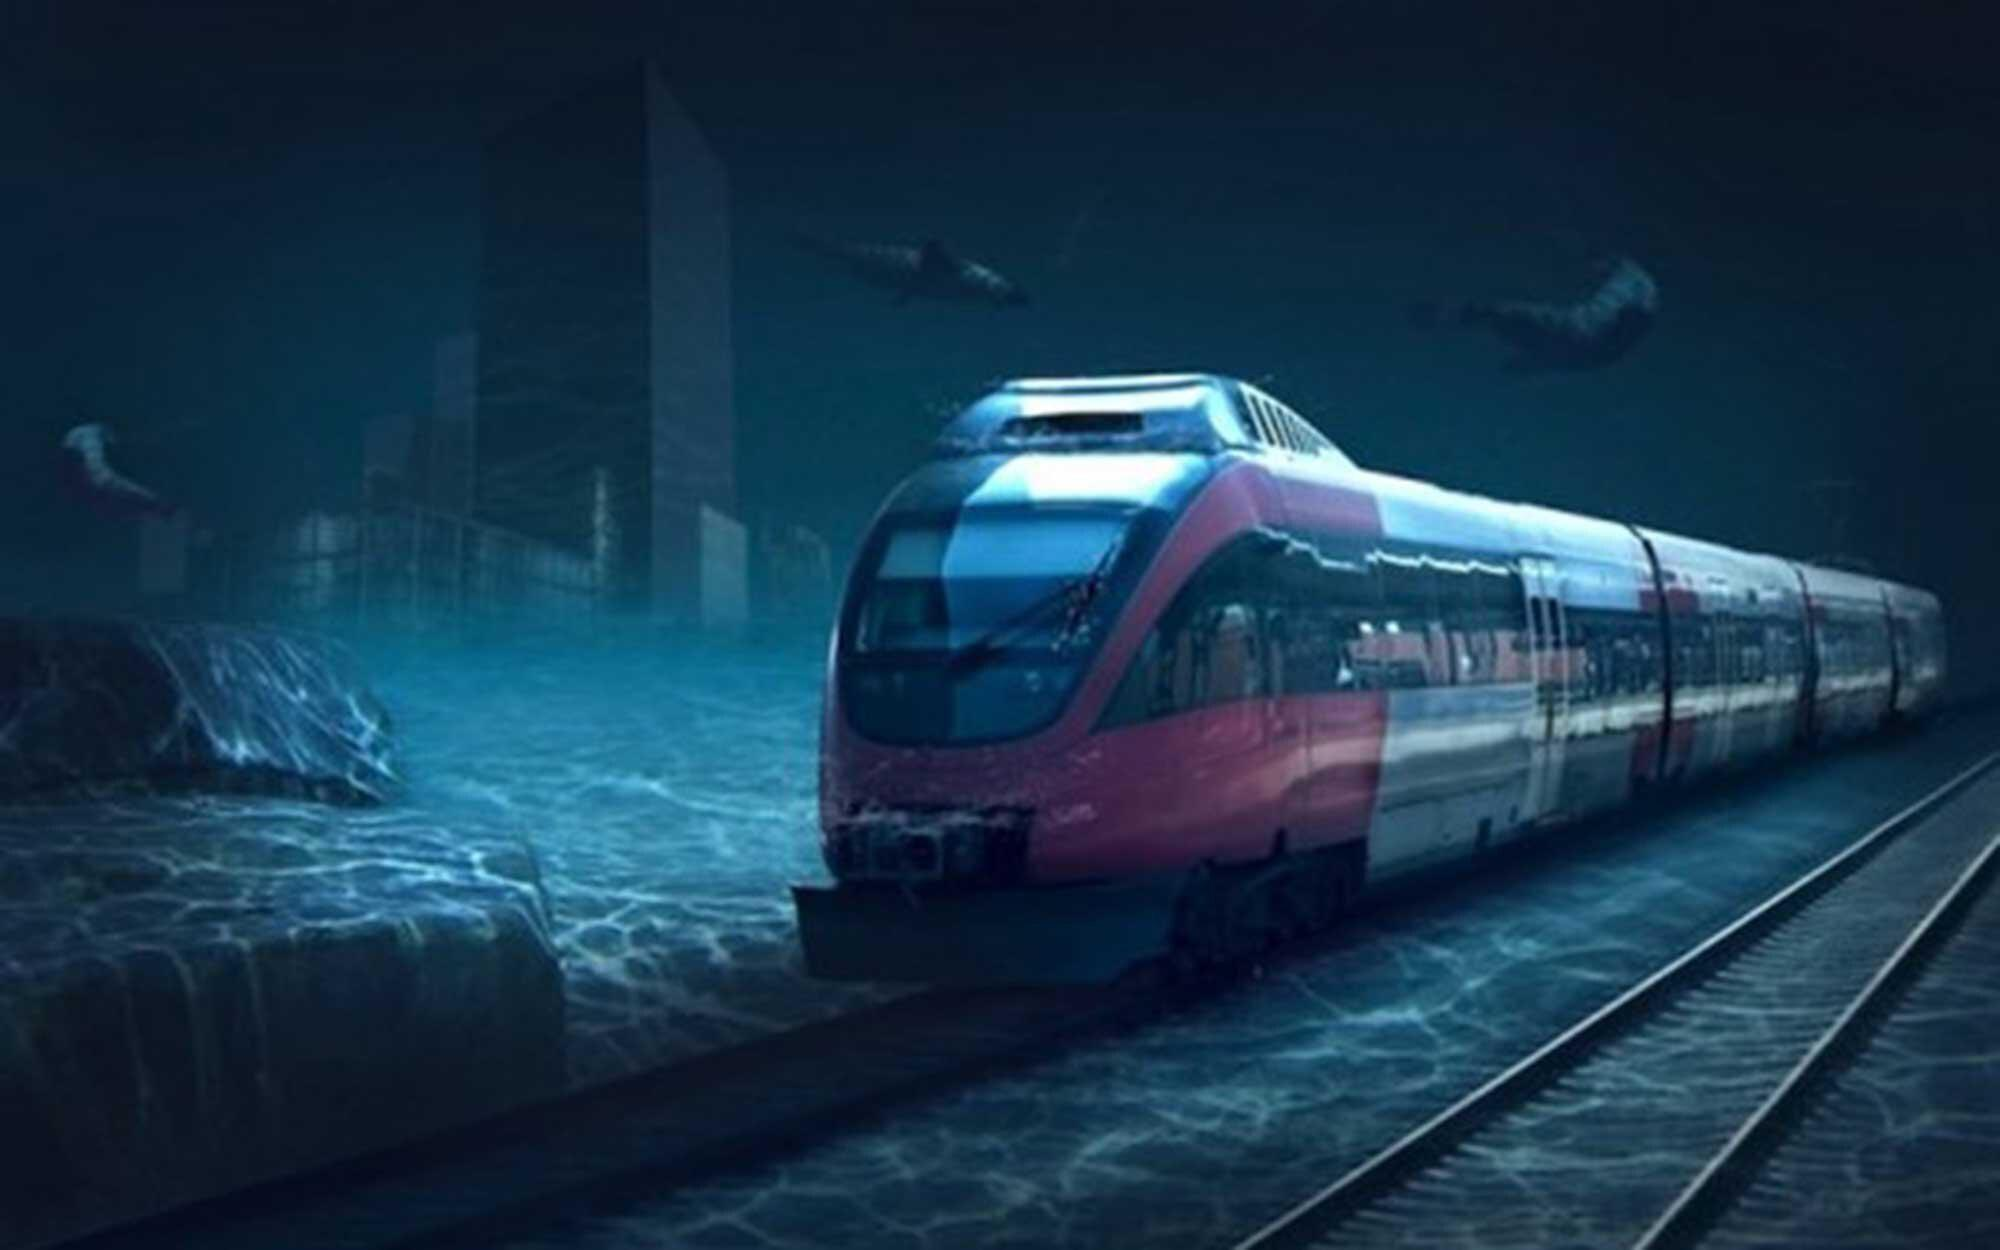What time of day does this scene depict? The scene seems to be set during the twilight hours; the ambient lighting suggests it's either dawn or dusk. The overall blue tone gives off a calm evening vibe, indicating that it might be just after sunset. 